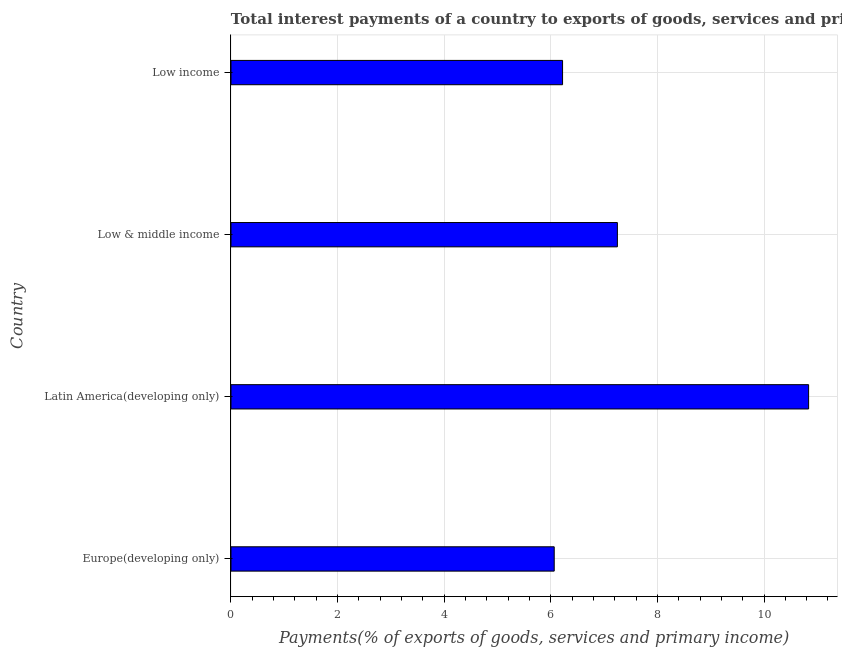What is the title of the graph?
Provide a short and direct response. Total interest payments of a country to exports of goods, services and primary income in 1994. What is the label or title of the X-axis?
Give a very brief answer. Payments(% of exports of goods, services and primary income). What is the label or title of the Y-axis?
Give a very brief answer. Country. What is the total interest payments on external debt in Europe(developing only)?
Provide a short and direct response. 6.06. Across all countries, what is the maximum total interest payments on external debt?
Give a very brief answer. 10.84. Across all countries, what is the minimum total interest payments on external debt?
Keep it short and to the point. 6.06. In which country was the total interest payments on external debt maximum?
Give a very brief answer. Latin America(developing only). In which country was the total interest payments on external debt minimum?
Your answer should be compact. Europe(developing only). What is the sum of the total interest payments on external debt?
Make the answer very short. 30.37. What is the difference between the total interest payments on external debt in Low & middle income and Low income?
Offer a very short reply. 1.03. What is the average total interest payments on external debt per country?
Your answer should be very brief. 7.59. What is the median total interest payments on external debt?
Your response must be concise. 6.74. What is the ratio of the total interest payments on external debt in Europe(developing only) to that in Low & middle income?
Offer a very short reply. 0.84. Is the difference between the total interest payments on external debt in Latin America(developing only) and Low & middle income greater than the difference between any two countries?
Provide a short and direct response. No. What is the difference between the highest and the second highest total interest payments on external debt?
Provide a short and direct response. 3.59. What is the difference between the highest and the lowest total interest payments on external debt?
Keep it short and to the point. 4.77. How many bars are there?
Offer a terse response. 4. Are all the bars in the graph horizontal?
Your answer should be very brief. Yes. Are the values on the major ticks of X-axis written in scientific E-notation?
Provide a succinct answer. No. What is the Payments(% of exports of goods, services and primary income) of Europe(developing only)?
Offer a very short reply. 6.06. What is the Payments(% of exports of goods, services and primary income) in Latin America(developing only)?
Offer a very short reply. 10.84. What is the Payments(% of exports of goods, services and primary income) in Low & middle income?
Provide a short and direct response. 7.25. What is the Payments(% of exports of goods, services and primary income) of Low income?
Ensure brevity in your answer.  6.22. What is the difference between the Payments(% of exports of goods, services and primary income) in Europe(developing only) and Latin America(developing only)?
Your response must be concise. -4.77. What is the difference between the Payments(% of exports of goods, services and primary income) in Europe(developing only) and Low & middle income?
Your response must be concise. -1.19. What is the difference between the Payments(% of exports of goods, services and primary income) in Europe(developing only) and Low income?
Ensure brevity in your answer.  -0.16. What is the difference between the Payments(% of exports of goods, services and primary income) in Latin America(developing only) and Low & middle income?
Your answer should be very brief. 3.59. What is the difference between the Payments(% of exports of goods, services and primary income) in Latin America(developing only) and Low income?
Your response must be concise. 4.62. What is the difference between the Payments(% of exports of goods, services and primary income) in Low & middle income and Low income?
Offer a very short reply. 1.03. What is the ratio of the Payments(% of exports of goods, services and primary income) in Europe(developing only) to that in Latin America(developing only)?
Keep it short and to the point. 0.56. What is the ratio of the Payments(% of exports of goods, services and primary income) in Europe(developing only) to that in Low & middle income?
Ensure brevity in your answer.  0.84. What is the ratio of the Payments(% of exports of goods, services and primary income) in Europe(developing only) to that in Low income?
Offer a very short reply. 0.97. What is the ratio of the Payments(% of exports of goods, services and primary income) in Latin America(developing only) to that in Low & middle income?
Your response must be concise. 1.5. What is the ratio of the Payments(% of exports of goods, services and primary income) in Latin America(developing only) to that in Low income?
Offer a very short reply. 1.74. What is the ratio of the Payments(% of exports of goods, services and primary income) in Low & middle income to that in Low income?
Offer a terse response. 1.17. 